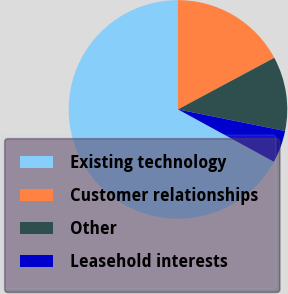Convert chart. <chart><loc_0><loc_0><loc_500><loc_500><pie_chart><fcel>Existing technology<fcel>Customer relationships<fcel>Other<fcel>Leasehold interests<nl><fcel>67.0%<fcel>17.22%<fcel>11.0%<fcel>4.78%<nl></chart> 